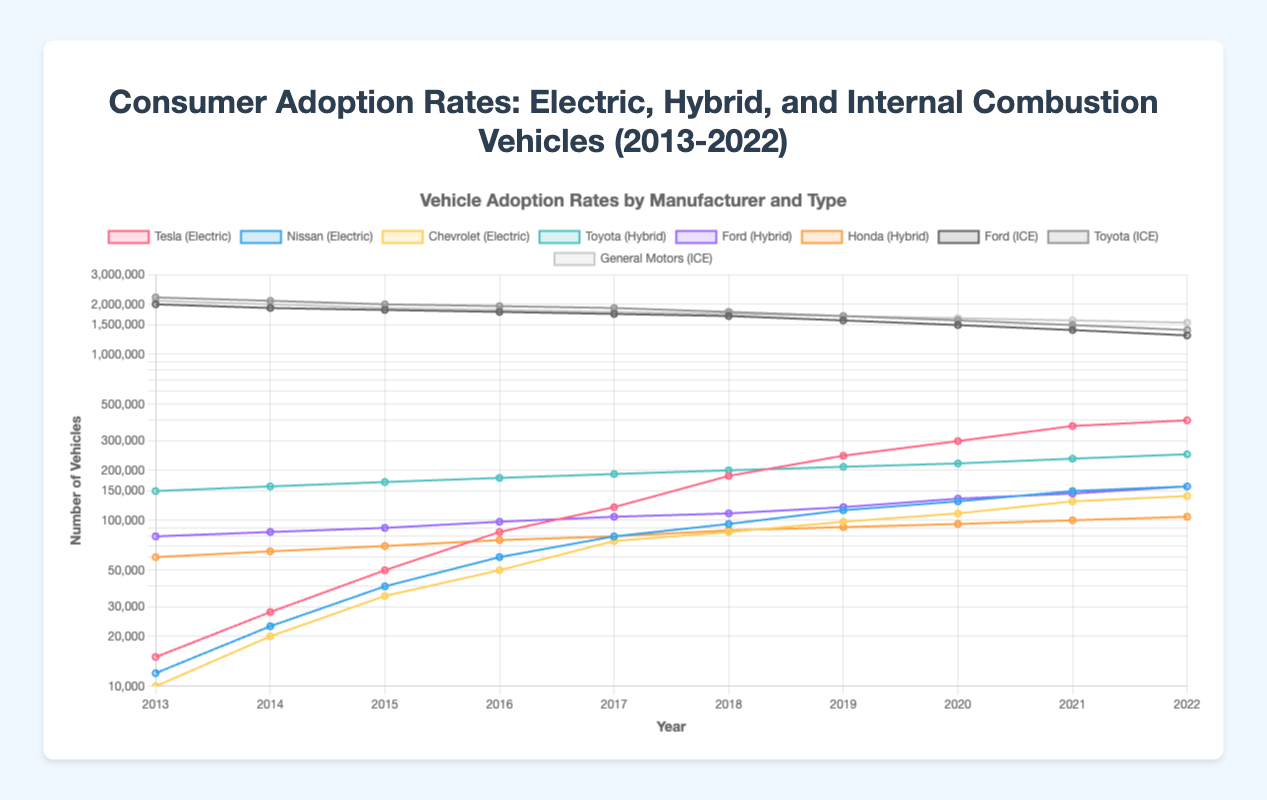What is the difference in the number of electric vehicles sold by Tesla and Nissan in 2022? In 2022, Tesla sold 400,000 electric vehicles and Nissan sold 160,000. The difference is calculated as 400,000 - 160,000.
Answer: 240,000 Between which two successive years did Toyota hybrid vehicles see the highest increase in adoption? Observing the data for Toyota hybrids, the highest increase occurred between 2021 (235,000 vehicles) and 2022 (250,000 vehicles). The increase is 250,000 - 235,000 = 15,000.
Answer: 2021 and 2022 Comparing the adoption rates of Ford vehicles, which type (hybrid or internal combustion engine) saw a greater decline or increase from 2013 to 2022? In 2013, Ford sold 80,000 hybrid vehicles, and by 2022, it increased to 160,000, a rise of 80,000. For internal combustion engines, Ford sold 2,000,000 in 2013 and 1,300,000 in 2022, a decline of 700,000.
Answer: Hybrid saw an increase, Internal Combustion Engine saw a decline Which car manufacturer had the highest number of hybrid vehicles sold in 2018? Looking at the data for 2018, Toyota sold 200,000 hybrid vehicles, Ford sold 110,000, and Honda sold 87,000, making Toyota the highest.
Answer: Toyota What is the average number of vehicles sold by Chevrolet electric vehicles from 2013 to 2022? Sum of Chevrolet electric vehicles sold from 2013 to 2022: 10,000 + 20,000 + 35,000 + 50,000 + 75,000 + 85,000 + 98,000 + 110,000 + 130,000 + 140,000 = 753,000. The average is 753,000 / 10.
Answer: 75,300 In which year did Tesla surpass the 200,000 mark for electric vehicle sales? Observing Tesla's sales figures, Tesla surpassed the 200,000 mark in the year 2018 with 245,000 vehicles sold.
Answer: 2018 Compare the trend of internal combustion engine vehicle adoption for Ford from 2013 to 2022. What general observation can be made? Analyzing the data, Ford's internal combustion engine vehicle sales dropped consistently from 2,000,000 in 2013 to 1,300,000 in 2022, indicating a declining trend.
Answer: Declining trend In which year did the adoption rate of electric vehicles for Nissan and Chevrolet combined first exceed 100,000? Adding sales figures for Nissan and Chevrolet, they first exceeded 100,000 combined in 2015 with Nissan at 40,000 and Chevrolet at 35,000, summing to 75,000, exceeding 100,000 in subsequent years.
Answer: 2017 What is the total number of hybrid vehicles sold by all manufacturers in 2020? Summing up hybrid vehicle sales in 2020: Toyota (220,000) + Ford (135,000) + Honda (95,000) = 450,000.
Answer: 450,000 